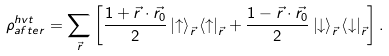Convert formula to latex. <formula><loc_0><loc_0><loc_500><loc_500>\rho ^ { h v t } _ { a f t e r } = \sum _ { \vec { r } } \left [ \frac { 1 + \vec { r } \cdot \vec { r _ { 0 } } } { 2 } \left | \uparrow \right > _ { \vec { r } } \left < \uparrow \right | _ { \vec { r } } + \frac { 1 - \vec { r } \cdot \vec { r _ { 0 } } } { 2 } \left | \downarrow \right > _ { \vec { r } } \left < \downarrow \right | _ { \vec { r } } \right ] .</formula> 